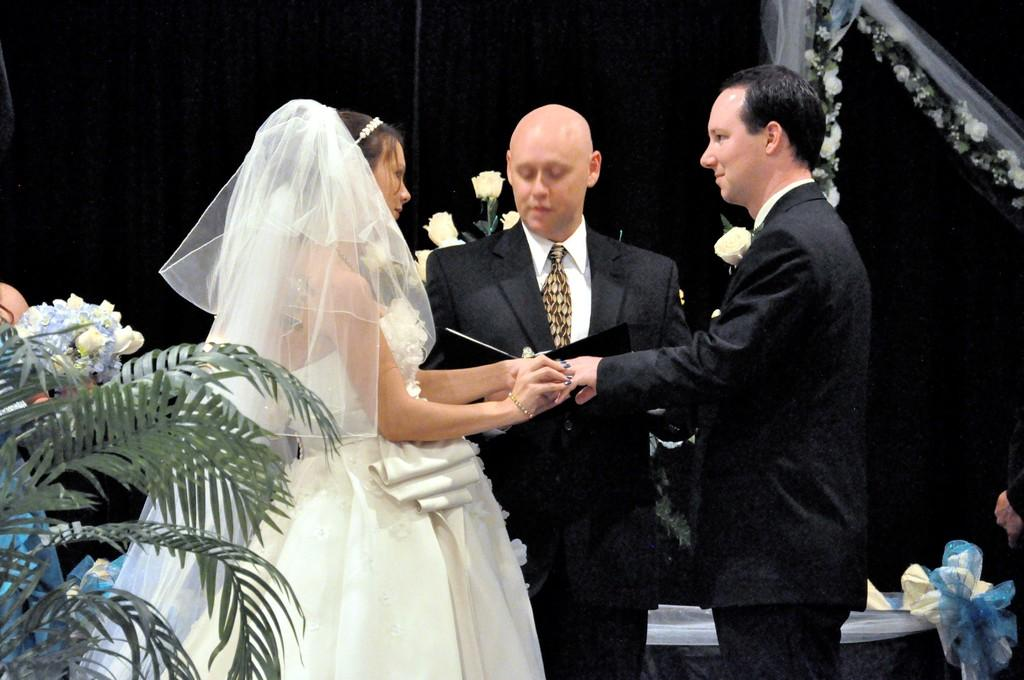How many people are in the image? There are three persons standing in the image. Where are the persons standing? The persons are standing on the floor. What type of plant can be seen in the image? There is a houseplant in the image. What can be seen in the background of the image? There is a curtain and flowers in the background of the image. Can you describe the setting where the image might have been taken? The image may have been taken in a hall. What story is being told by the swing in the image? There is no swing present in the image, so no story can be associated with it. 